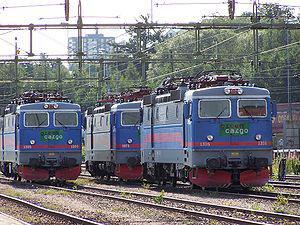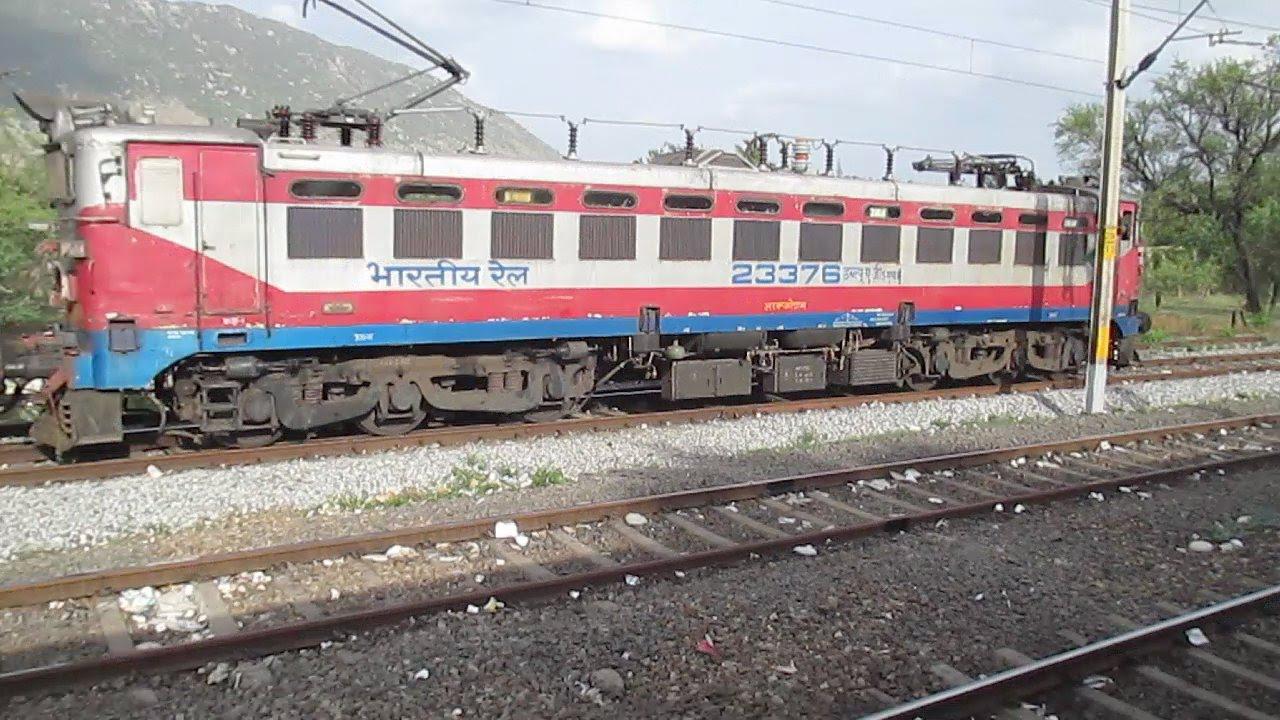The first image is the image on the left, the second image is the image on the right. Evaluate the accuracy of this statement regarding the images: "There are two trains in total traveling in opposite direction.". Is it true? Answer yes or no. No. The first image is the image on the left, the second image is the image on the right. For the images displayed, is the sentence "There are multiple trains in the image on the left." factually correct? Answer yes or no. Yes. 